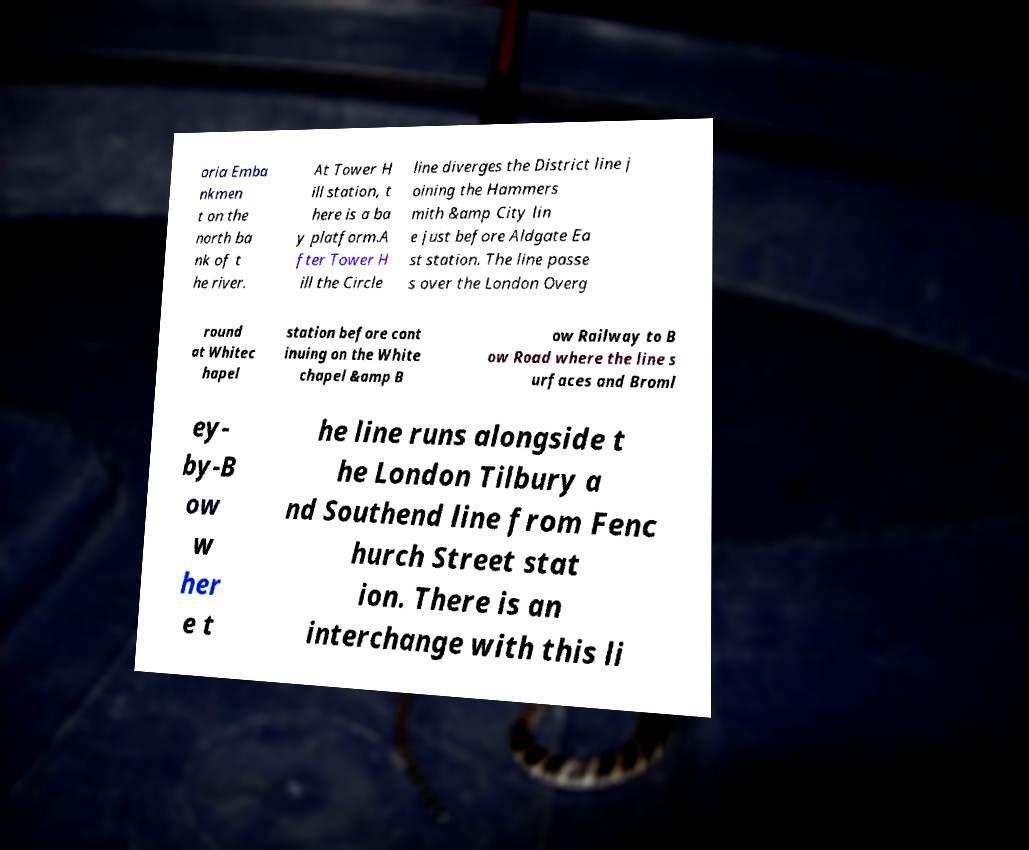For documentation purposes, I need the text within this image transcribed. Could you provide that? oria Emba nkmen t on the north ba nk of t he river. At Tower H ill station, t here is a ba y platform.A fter Tower H ill the Circle line diverges the District line j oining the Hammers mith &amp City lin e just before Aldgate Ea st station. The line passe s over the London Overg round at Whitec hapel station before cont inuing on the White chapel &amp B ow Railway to B ow Road where the line s urfaces and Broml ey- by-B ow w her e t he line runs alongside t he London Tilbury a nd Southend line from Fenc hurch Street stat ion. There is an interchange with this li 